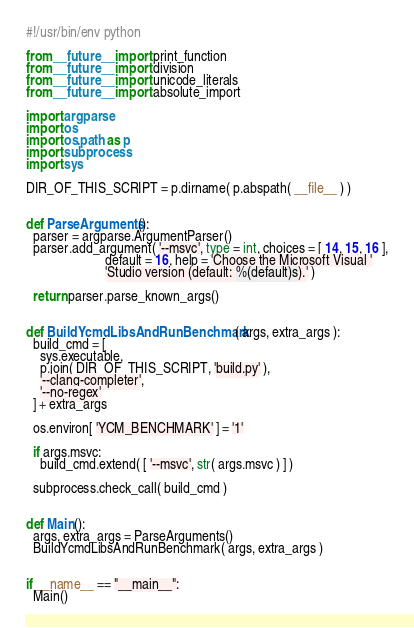<code> <loc_0><loc_0><loc_500><loc_500><_Python_>#!/usr/bin/env python

from __future__ import print_function
from __future__ import division
from __future__ import unicode_literals
from __future__ import absolute_import

import argparse
import os
import os.path as p
import subprocess
import sys

DIR_OF_THIS_SCRIPT = p.dirname( p.abspath( __file__ ) )


def ParseArguments():
  parser = argparse.ArgumentParser()
  parser.add_argument( '--msvc', type = int, choices = [ 14, 15, 16 ],
                       default = 16, help = 'Choose the Microsoft Visual '
                       'Studio version (default: %(default)s).' )

  return parser.parse_known_args()


def BuildYcmdLibsAndRunBenchmark( args, extra_args ):
  build_cmd = [
    sys.executable,
    p.join( DIR_OF_THIS_SCRIPT, 'build.py' ),
    '--clang-completer',
    '--no-regex'
  ] + extra_args

  os.environ[ 'YCM_BENCHMARK' ] = '1'

  if args.msvc:
    build_cmd.extend( [ '--msvc', str( args.msvc ) ] )

  subprocess.check_call( build_cmd )


def Main():
  args, extra_args = ParseArguments()
  BuildYcmdLibsAndRunBenchmark( args, extra_args )


if __name__ == "__main__":
  Main()
</code> 